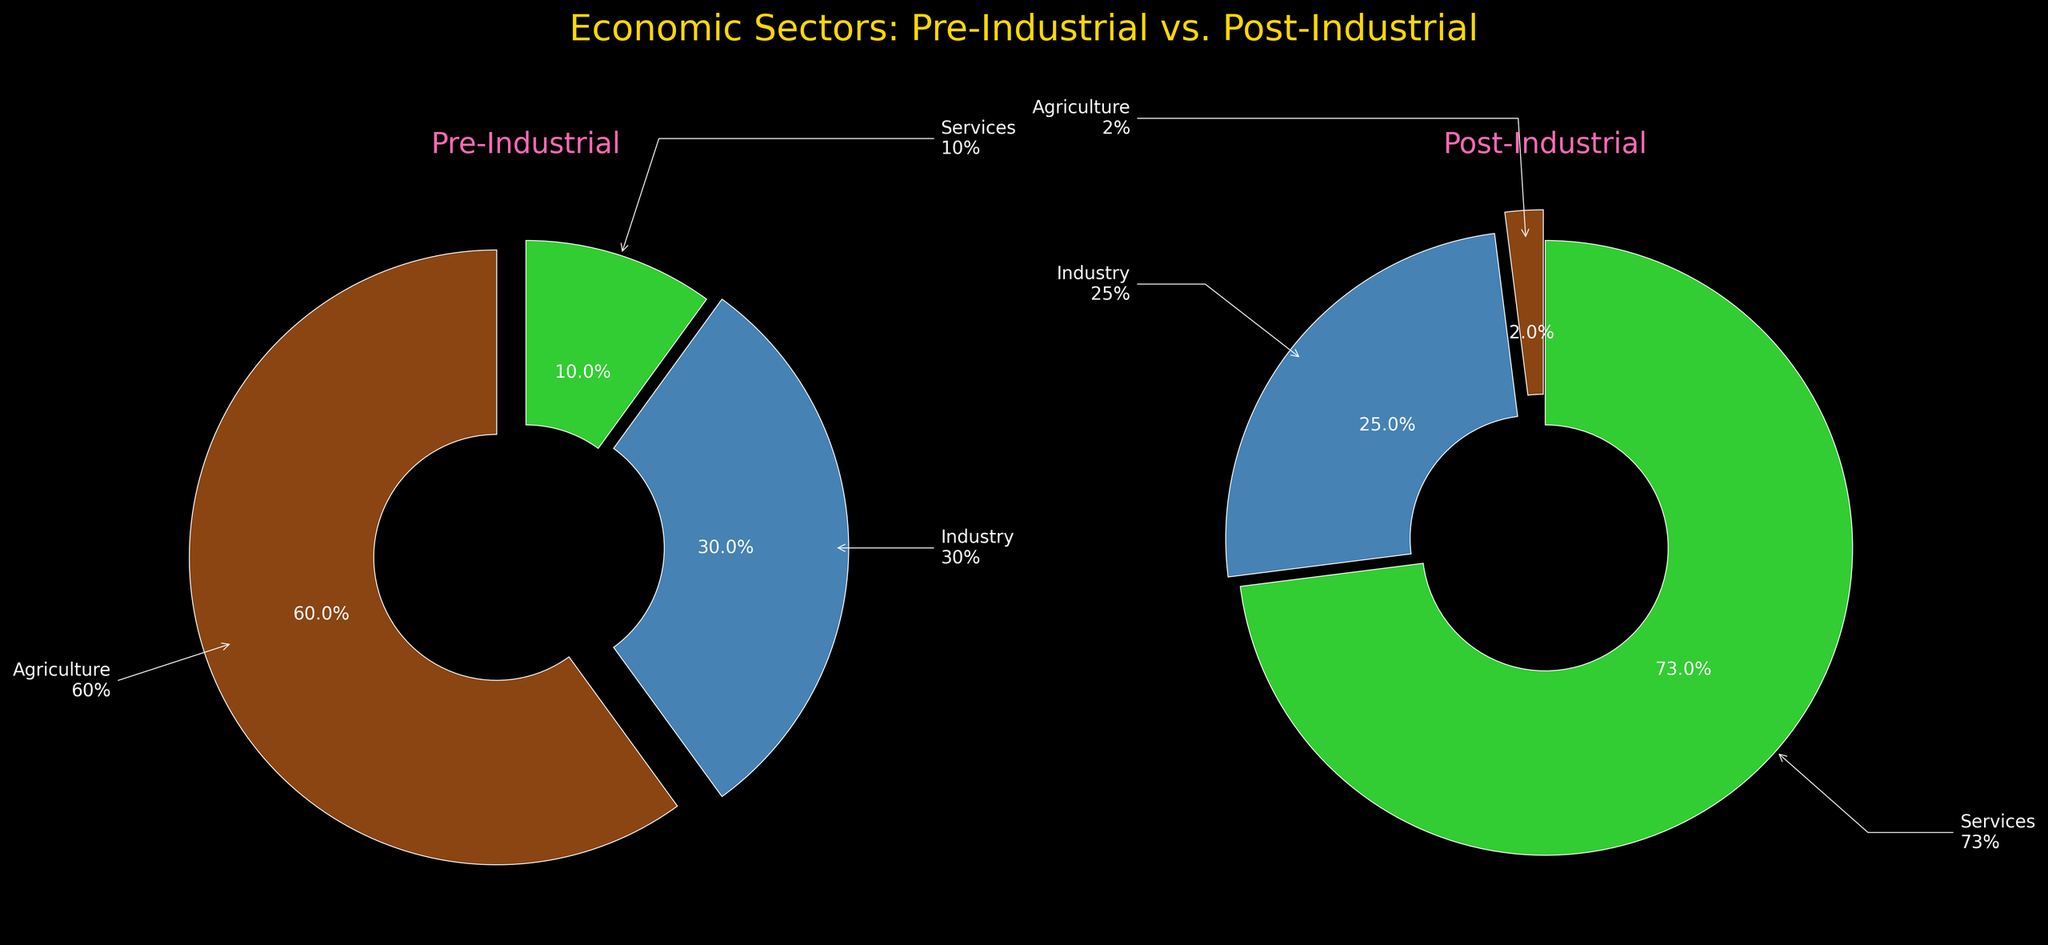What is the percentage difference in the workforce engaged in agriculture between pre-industrial and post-industrial societies? The percentage of the workforce in agriculture is 60% in pre-industrial and 2% in post-industrial societies. The difference is 60 - 2 = 58%
Answer: 58% Between pre-industrial and post-industrial societies, which sector shows the largest increase in workforce percentage? Comparing the increases: agriculture decreases from 60% to 2% (a decrease), industry changes from 30% to 25% (a decrease), and services increase from 10% to 73%. The largest increase is in services.
Answer: Services How many times larger is the workforce percentage in agriculture in pre-industrial compared to post-industrial societies? The workforce in agriculture in pre-industrial societies is 60%. In post-industrial societies, it is 2%. The ratio is 60 / 2 = 30 times larger.
Answer: 30 times What is the combined workforce percentage for industry and services in post-industrial societies? In post-industrial societies, industry and services make up 25% and 73% of the workforce, respectively. The combined percentage is 25 + 73 = 98%.
Answer: 98% Which sector has more than half of the workforce in post-industrial societies? In post-industrial societies, services have 73% of the workforce, which is more than half.
Answer: Services Compare the industry sector's workforce percentage in pre-industrial and post-industrial societies. The workforce percentage in the industry sector is 30% in pre-industrial societies and 25% in post-industrial societies. The pre-industrial percentage is higher.
Answer: Pre-Industrial If the total workforce is split into 100 units, how many units are engaged in services in a post-industrial society? In a post-industrial society, 73% of the workforce is engaged in services. For 100 units, this translates to 73 units.
Answer: 73 units In terms of the visual elements, which sector in pre-industrial societies is represented by a wedge with an orange-brown color? In pre-industrial societies, the sector with an orange-brown color is agriculture, which has the largest wedge.
Answer: Agriculture Which sector shows the smallest percentage in post-industrial societies? In post-industrial societies, the smallest percentage is in the agriculture sector, which accounts for 2% of the workforce.
Answer: Agriculture How does the proportion of the workforce in the services sector of post-industrial societies compare to the total proportion of industry and agriculture together in the same period? In post-industrial societies, the services sector accounts for 73% of the workforce, while the combined total for industry (25%) and agriculture (2%) is 27%. Services have a higher proportion.
Answer: Services have a higher proportion 